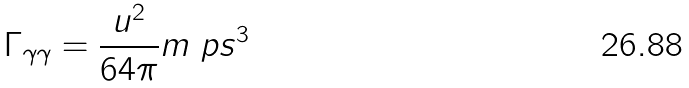Convert formula to latex. <formula><loc_0><loc_0><loc_500><loc_500>\Gamma _ { \gamma \gamma } = \frac { u ^ { 2 } } { 6 4 \pi } m _ { \ } p s ^ { 3 }</formula> 